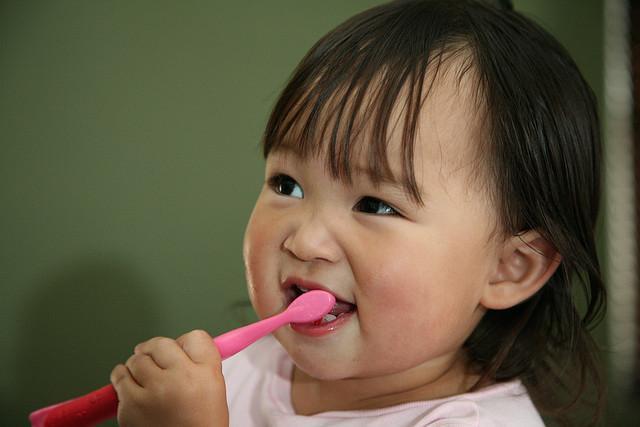How many giraffes are leaning over the woman's left shoulder?
Give a very brief answer. 0. 